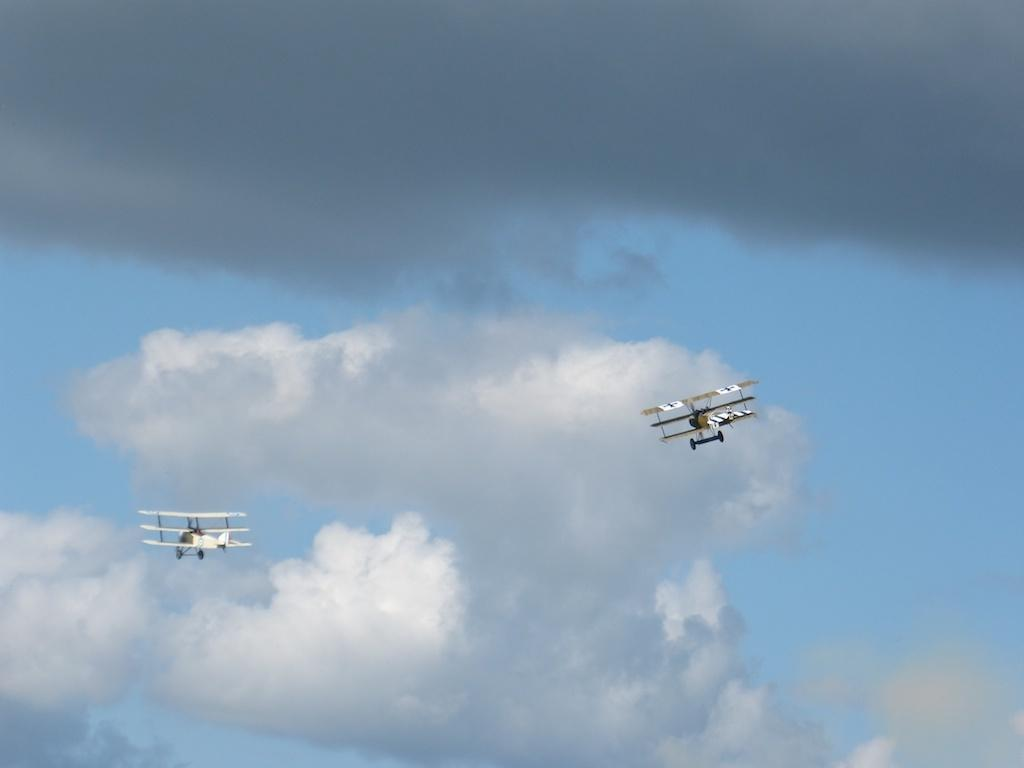What is the main subject of the image? The main subject of the image is two aircrafts. Where are the aircrafts located in the image? The aircrafts are flying in the sky. What type of brass material can be seen on the houses in the image? There are no houses present in the image, and therefore no brass material can be observed. 